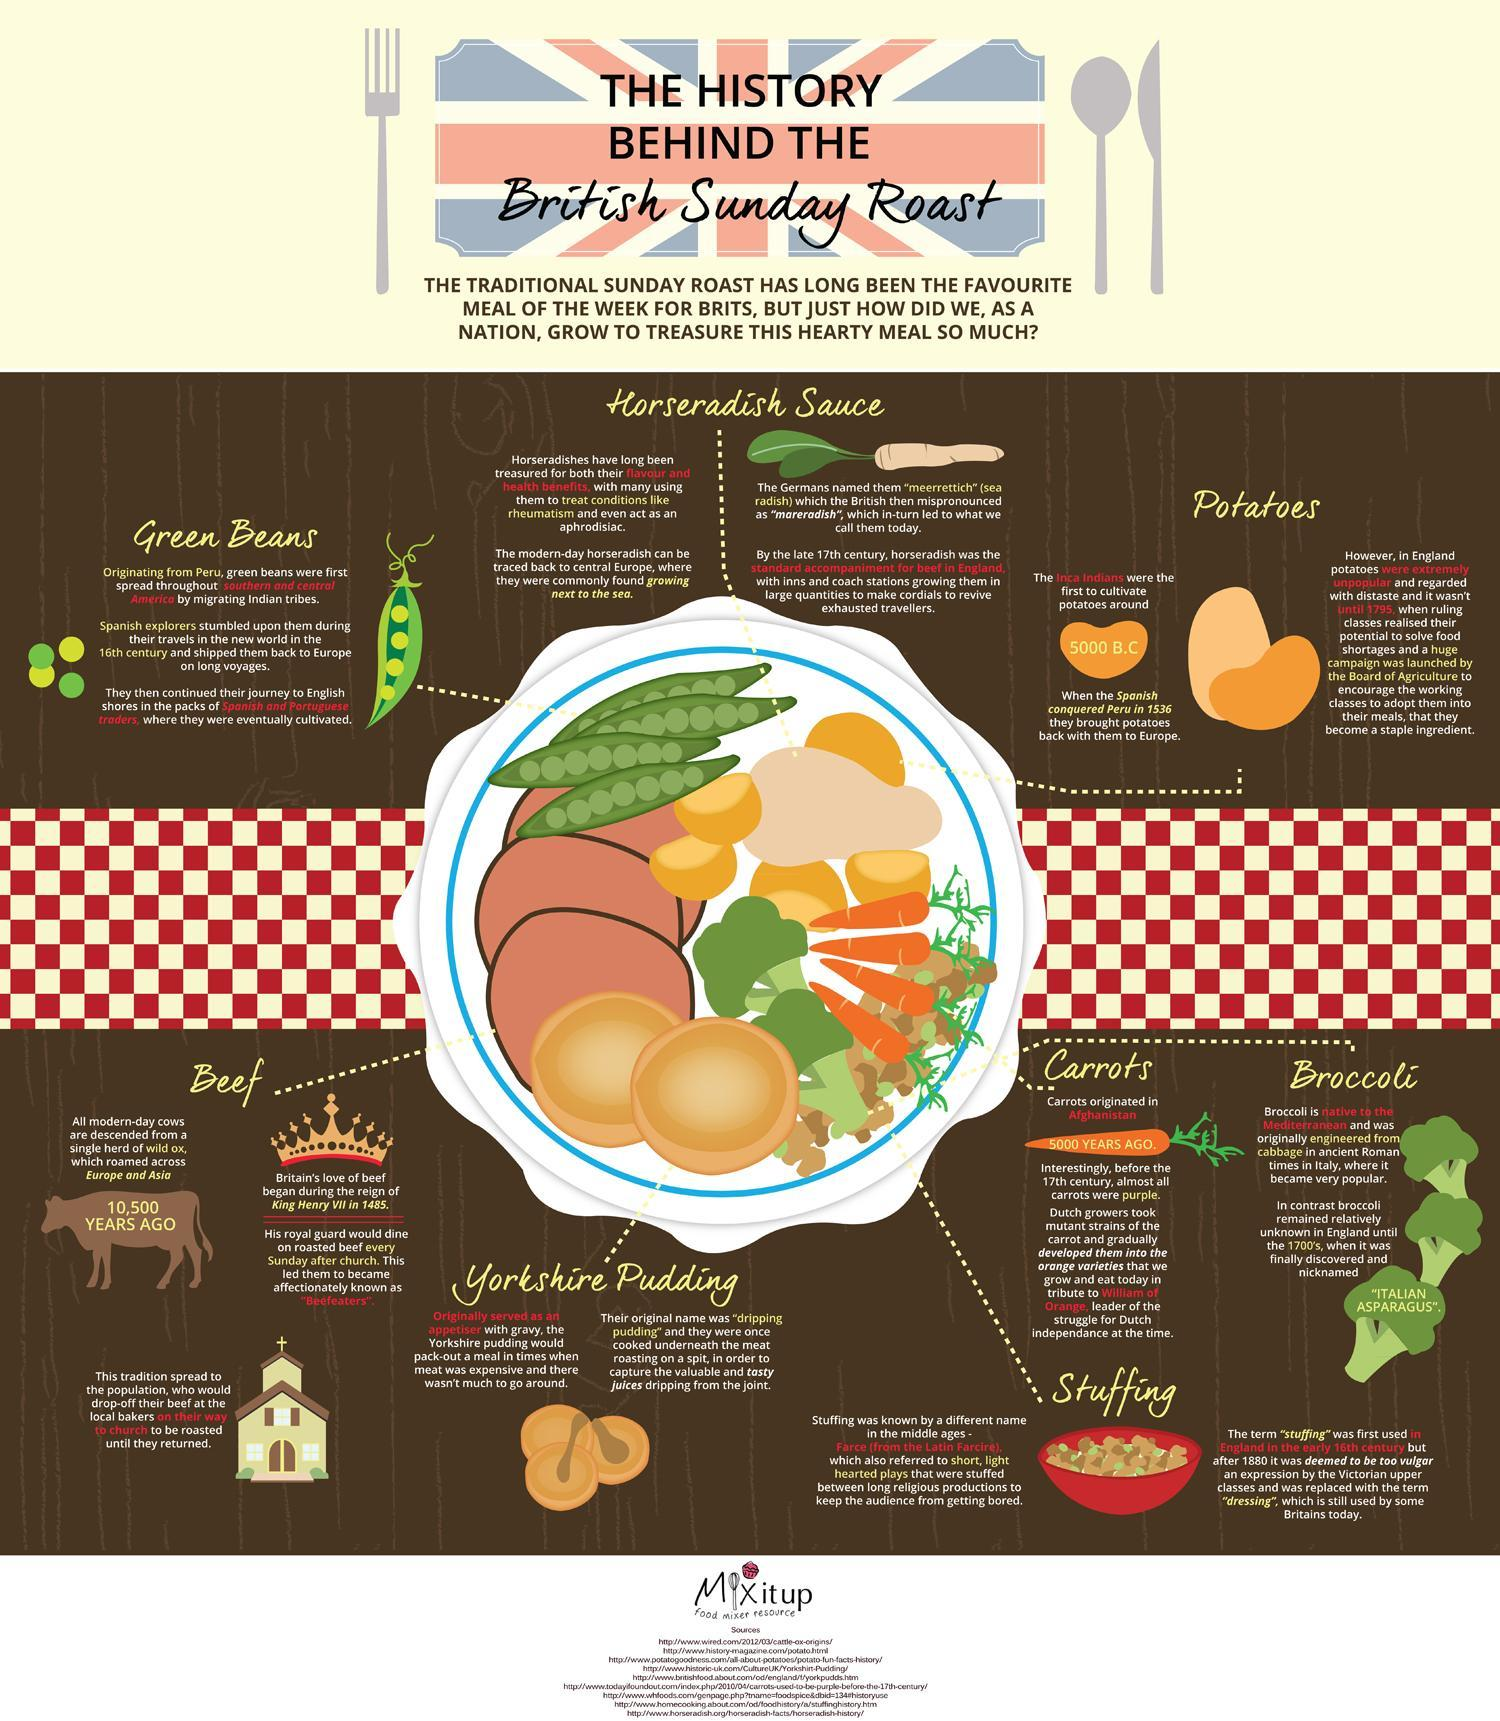What is the original name of yorkshire pudding?
Answer the question with a short phrase. "dripping pudding" What was the nickname given to broccoli when it was first introduced in England in the mid 18th century? "ITALIAN ASPARAGUS". 